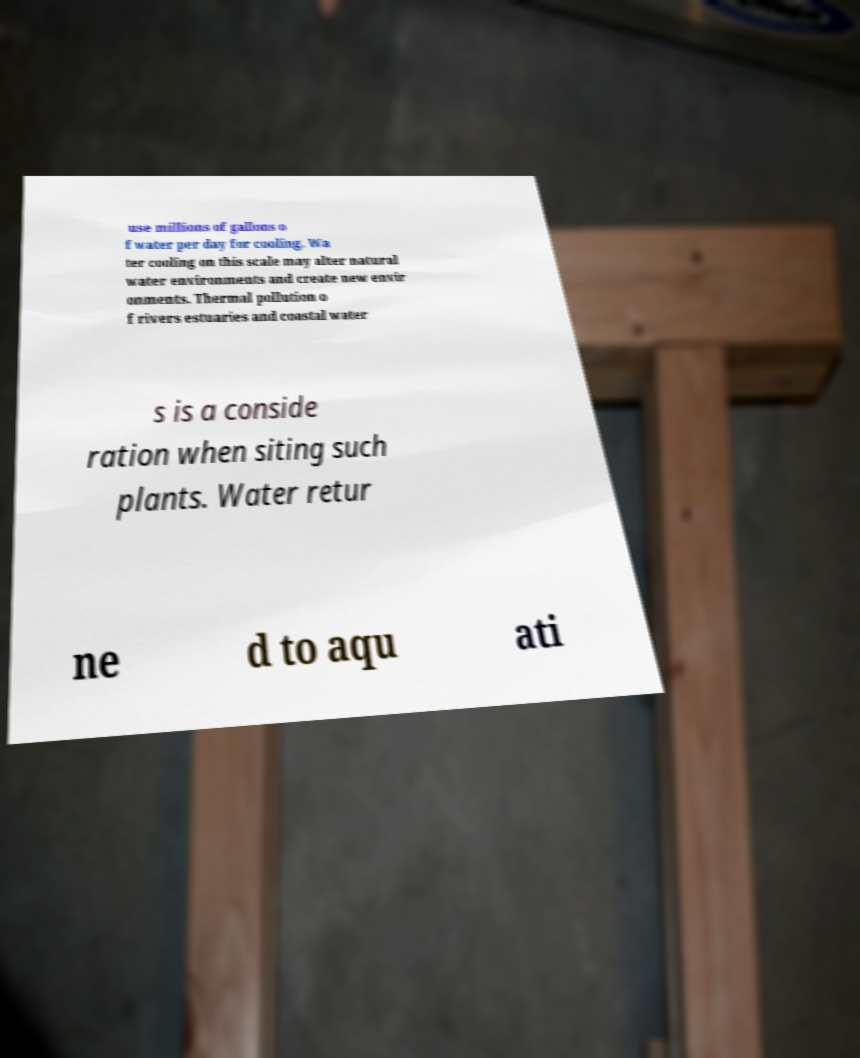There's text embedded in this image that I need extracted. Can you transcribe it verbatim? use millions of gallons o f water per day for cooling. Wa ter cooling on this scale may alter natural water environments and create new envir onments. Thermal pollution o f rivers estuaries and coastal water s is a conside ration when siting such plants. Water retur ne d to aqu ati 